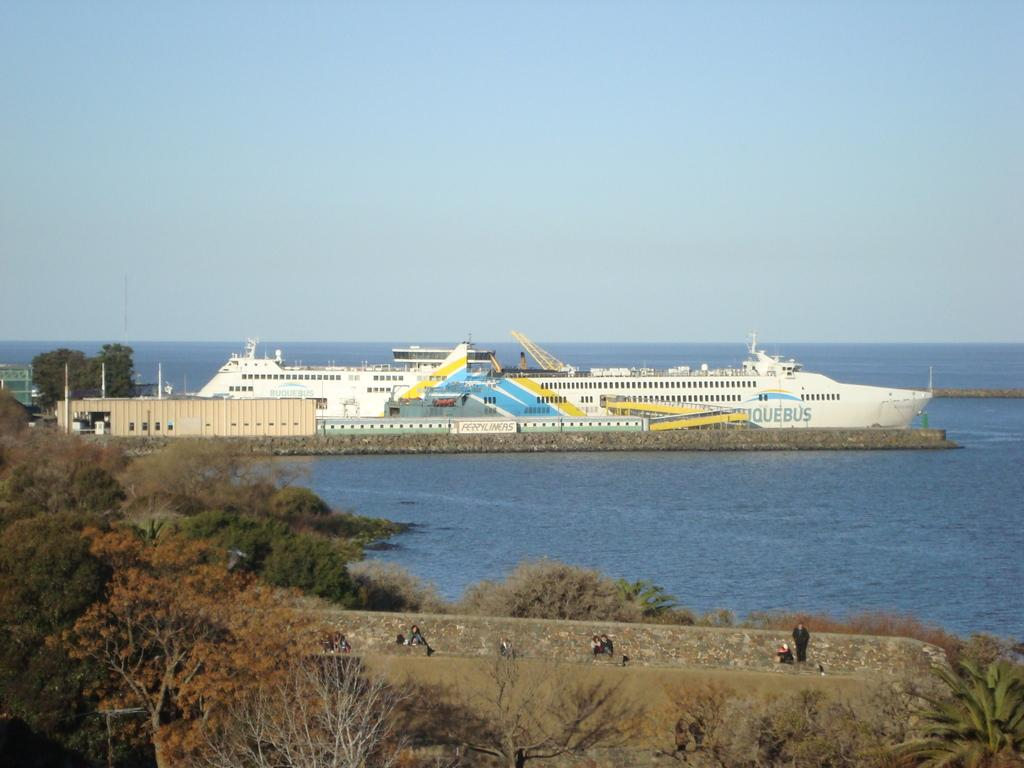Who or what can be seen in the image? There are people in the image. What type of natural elements are present in the image? There are trees in the image. What type of man-made structures are present in the image? There are walls in the image. What other objects can be seen in the image? There are objects in the image. What is the main subject on the water in the image? There is a ship on the water in the image. What is visible in the background of the image? The sky is visible in the background of the image. What type of street can be seen in the image? There is no street present in the image. What type of relation can be observed between the people in the image? The image does not provide enough information to determine the relationship between the people. 